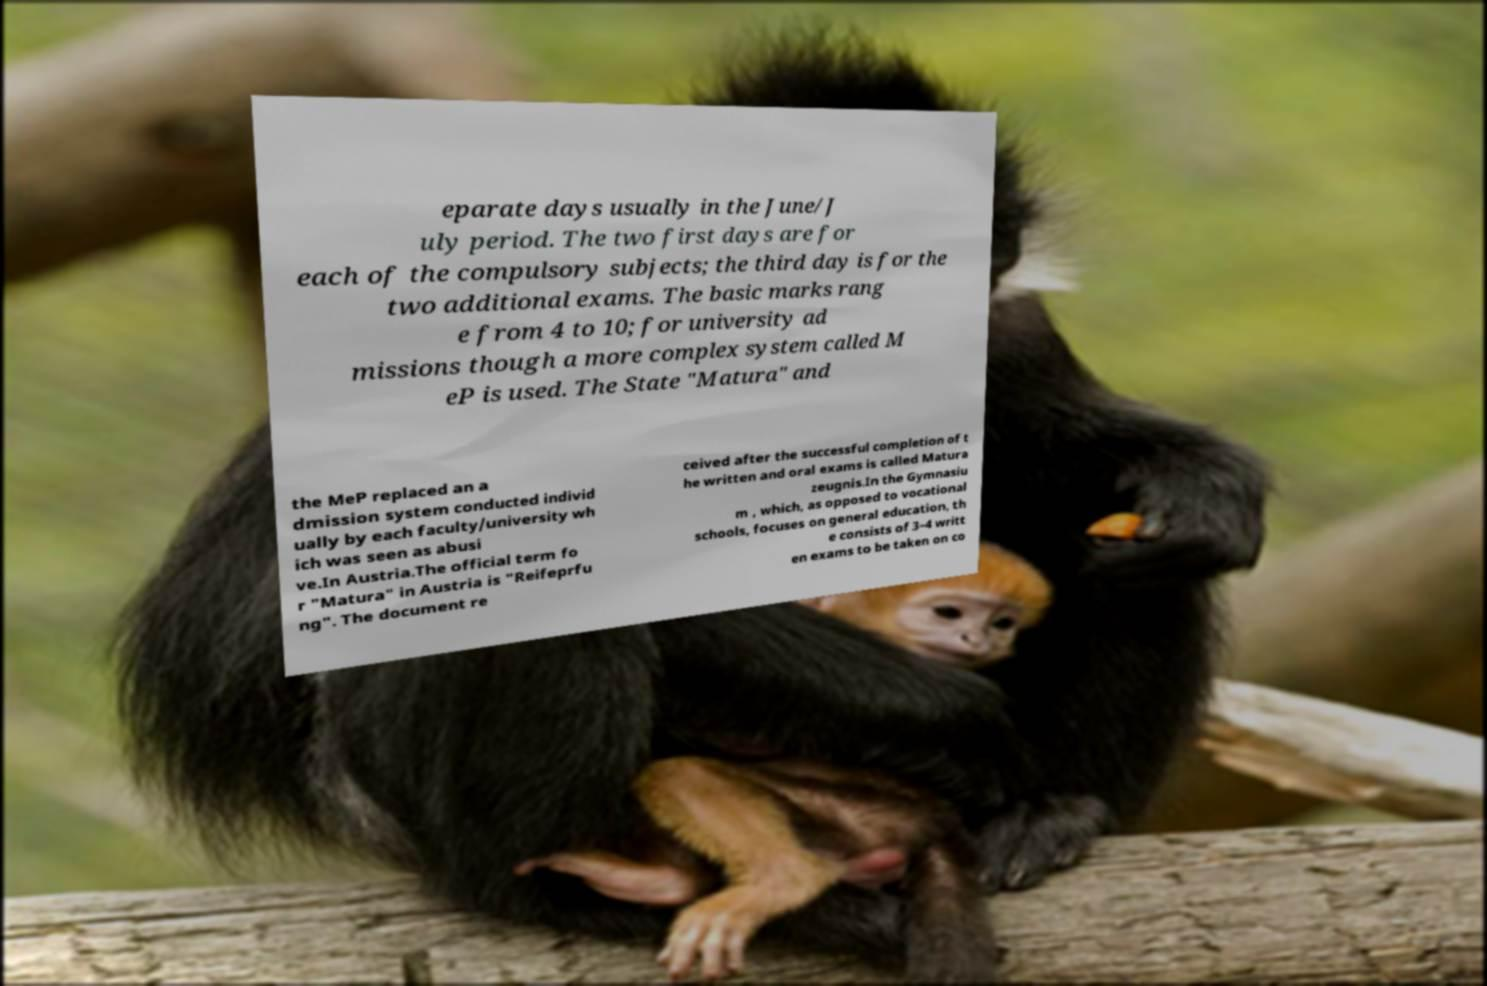Could you assist in decoding the text presented in this image and type it out clearly? eparate days usually in the June/J uly period. The two first days are for each of the compulsory subjects; the third day is for the two additional exams. The basic marks rang e from 4 to 10; for university ad missions though a more complex system called M eP is used. The State "Matura" and the MeP replaced an a dmission system conducted individ ually by each faculty/university wh ich was seen as abusi ve.In Austria.The official term fo r "Matura" in Austria is "Reifeprfu ng". The document re ceived after the successful completion of t he written and oral exams is called Matura zeugnis.In the Gymnasiu m , which, as opposed to vocational schools, focuses on general education, th e consists of 3–4 writt en exams to be taken on co 